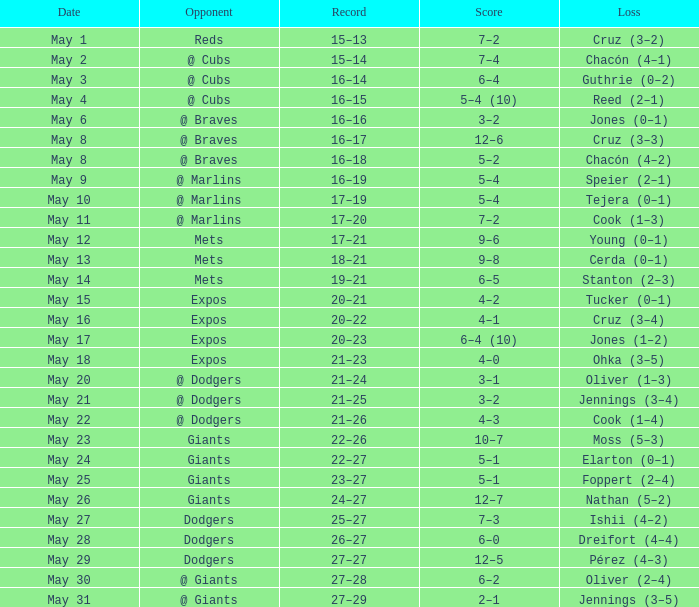Tell me who was the opponent on May 6 @ Braves. 